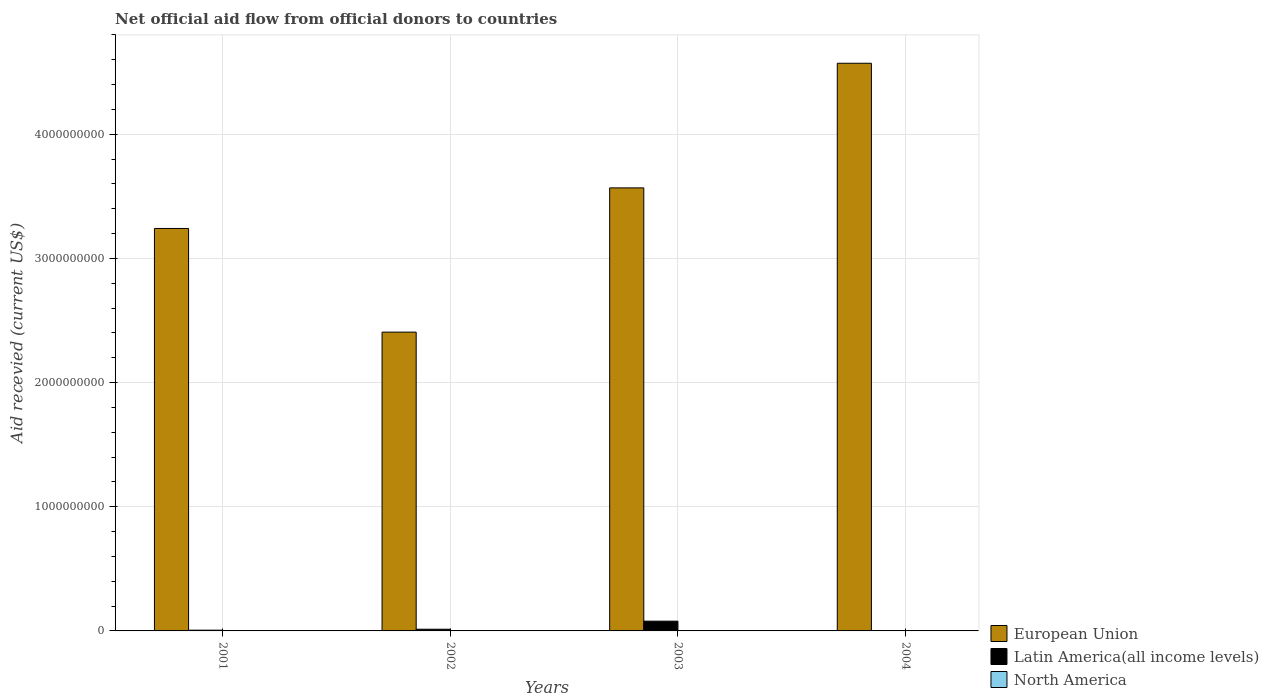How many groups of bars are there?
Provide a short and direct response. 4. Are the number of bars on each tick of the X-axis equal?
Ensure brevity in your answer.  No. How many bars are there on the 4th tick from the left?
Make the answer very short. 2. How many bars are there on the 1st tick from the right?
Make the answer very short. 2. What is the total aid received in North America in 2003?
Make the answer very short. 3.00e+04. Across all years, what is the maximum total aid received in European Union?
Offer a terse response. 4.57e+09. What is the difference between the total aid received in North America in 2001 and that in 2002?
Ensure brevity in your answer.  0. What is the difference between the total aid received in European Union in 2003 and the total aid received in Latin America(all income levels) in 2002?
Ensure brevity in your answer.  3.55e+09. What is the average total aid received in Latin America(all income levels) per year?
Offer a terse response. 2.46e+07. In the year 2002, what is the difference between the total aid received in Latin America(all income levels) and total aid received in North America?
Ensure brevity in your answer.  1.37e+07. In how many years, is the total aid received in European Union greater than 3600000000 US$?
Keep it short and to the point. 1. What is the ratio of the total aid received in European Union in 2001 to that in 2002?
Provide a short and direct response. 1.35. What is the difference between the highest and the second highest total aid received in Latin America(all income levels)?
Your answer should be compact. 6.49e+07. Is the sum of the total aid received in European Union in 2002 and 2003 greater than the maximum total aid received in North America across all years?
Make the answer very short. Yes. How many bars are there?
Keep it short and to the point. 11. Are all the bars in the graph horizontal?
Provide a succinct answer. No. How many years are there in the graph?
Make the answer very short. 4. Are the values on the major ticks of Y-axis written in scientific E-notation?
Make the answer very short. No. Does the graph contain grids?
Offer a very short reply. Yes. Where does the legend appear in the graph?
Make the answer very short. Bottom right. How are the legend labels stacked?
Keep it short and to the point. Vertical. What is the title of the graph?
Ensure brevity in your answer.  Net official aid flow from official donors to countries. What is the label or title of the Y-axis?
Your answer should be compact. Aid recevied (current US$). What is the Aid recevied (current US$) in European Union in 2001?
Give a very brief answer. 3.24e+09. What is the Aid recevied (current US$) of Latin America(all income levels) in 2001?
Provide a short and direct response. 5.97e+06. What is the Aid recevied (current US$) in North America in 2001?
Your response must be concise. 2.00e+04. What is the Aid recevied (current US$) of European Union in 2002?
Offer a very short reply. 2.41e+09. What is the Aid recevied (current US$) in Latin America(all income levels) in 2002?
Offer a very short reply. 1.37e+07. What is the Aid recevied (current US$) in North America in 2002?
Provide a short and direct response. 2.00e+04. What is the Aid recevied (current US$) in European Union in 2003?
Provide a short and direct response. 3.57e+09. What is the Aid recevied (current US$) of Latin America(all income levels) in 2003?
Give a very brief answer. 7.86e+07. What is the Aid recevied (current US$) in European Union in 2004?
Ensure brevity in your answer.  4.57e+09. Across all years, what is the maximum Aid recevied (current US$) of European Union?
Make the answer very short. 4.57e+09. Across all years, what is the maximum Aid recevied (current US$) of Latin America(all income levels)?
Ensure brevity in your answer.  7.86e+07. Across all years, what is the minimum Aid recevied (current US$) in European Union?
Give a very brief answer. 2.41e+09. Across all years, what is the minimum Aid recevied (current US$) in Latin America(all income levels)?
Ensure brevity in your answer.  0. Across all years, what is the minimum Aid recevied (current US$) in North America?
Make the answer very short. 2.00e+04. What is the total Aid recevied (current US$) in European Union in the graph?
Offer a very short reply. 1.38e+1. What is the total Aid recevied (current US$) of Latin America(all income levels) in the graph?
Keep it short and to the point. 9.82e+07. What is the total Aid recevied (current US$) of North America in the graph?
Your answer should be compact. 1.60e+05. What is the difference between the Aid recevied (current US$) in European Union in 2001 and that in 2002?
Give a very brief answer. 8.35e+08. What is the difference between the Aid recevied (current US$) in Latin America(all income levels) in 2001 and that in 2002?
Provide a succinct answer. -7.74e+06. What is the difference between the Aid recevied (current US$) of North America in 2001 and that in 2002?
Offer a terse response. 0. What is the difference between the Aid recevied (current US$) of European Union in 2001 and that in 2003?
Make the answer very short. -3.27e+08. What is the difference between the Aid recevied (current US$) of Latin America(all income levels) in 2001 and that in 2003?
Offer a very short reply. -7.26e+07. What is the difference between the Aid recevied (current US$) of European Union in 2001 and that in 2004?
Give a very brief answer. -1.33e+09. What is the difference between the Aid recevied (current US$) of North America in 2001 and that in 2004?
Give a very brief answer. -7.00e+04. What is the difference between the Aid recevied (current US$) in European Union in 2002 and that in 2003?
Your answer should be compact. -1.16e+09. What is the difference between the Aid recevied (current US$) in Latin America(all income levels) in 2002 and that in 2003?
Give a very brief answer. -6.49e+07. What is the difference between the Aid recevied (current US$) in European Union in 2002 and that in 2004?
Provide a succinct answer. -2.17e+09. What is the difference between the Aid recevied (current US$) of European Union in 2003 and that in 2004?
Your answer should be compact. -1.00e+09. What is the difference between the Aid recevied (current US$) of European Union in 2001 and the Aid recevied (current US$) of Latin America(all income levels) in 2002?
Offer a very short reply. 3.23e+09. What is the difference between the Aid recevied (current US$) of European Union in 2001 and the Aid recevied (current US$) of North America in 2002?
Provide a short and direct response. 3.24e+09. What is the difference between the Aid recevied (current US$) of Latin America(all income levels) in 2001 and the Aid recevied (current US$) of North America in 2002?
Give a very brief answer. 5.95e+06. What is the difference between the Aid recevied (current US$) of European Union in 2001 and the Aid recevied (current US$) of Latin America(all income levels) in 2003?
Your answer should be very brief. 3.16e+09. What is the difference between the Aid recevied (current US$) in European Union in 2001 and the Aid recevied (current US$) in North America in 2003?
Make the answer very short. 3.24e+09. What is the difference between the Aid recevied (current US$) of Latin America(all income levels) in 2001 and the Aid recevied (current US$) of North America in 2003?
Provide a succinct answer. 5.94e+06. What is the difference between the Aid recevied (current US$) in European Union in 2001 and the Aid recevied (current US$) in North America in 2004?
Offer a terse response. 3.24e+09. What is the difference between the Aid recevied (current US$) of Latin America(all income levels) in 2001 and the Aid recevied (current US$) of North America in 2004?
Offer a terse response. 5.88e+06. What is the difference between the Aid recevied (current US$) in European Union in 2002 and the Aid recevied (current US$) in Latin America(all income levels) in 2003?
Your answer should be compact. 2.33e+09. What is the difference between the Aid recevied (current US$) of European Union in 2002 and the Aid recevied (current US$) of North America in 2003?
Your response must be concise. 2.41e+09. What is the difference between the Aid recevied (current US$) of Latin America(all income levels) in 2002 and the Aid recevied (current US$) of North America in 2003?
Your answer should be very brief. 1.37e+07. What is the difference between the Aid recevied (current US$) of European Union in 2002 and the Aid recevied (current US$) of North America in 2004?
Offer a terse response. 2.41e+09. What is the difference between the Aid recevied (current US$) of Latin America(all income levels) in 2002 and the Aid recevied (current US$) of North America in 2004?
Ensure brevity in your answer.  1.36e+07. What is the difference between the Aid recevied (current US$) of European Union in 2003 and the Aid recevied (current US$) of North America in 2004?
Your answer should be very brief. 3.57e+09. What is the difference between the Aid recevied (current US$) in Latin America(all income levels) in 2003 and the Aid recevied (current US$) in North America in 2004?
Your response must be concise. 7.85e+07. What is the average Aid recevied (current US$) in European Union per year?
Your answer should be compact. 3.45e+09. What is the average Aid recevied (current US$) in Latin America(all income levels) per year?
Your answer should be very brief. 2.46e+07. In the year 2001, what is the difference between the Aid recevied (current US$) of European Union and Aid recevied (current US$) of Latin America(all income levels)?
Give a very brief answer. 3.24e+09. In the year 2001, what is the difference between the Aid recevied (current US$) of European Union and Aid recevied (current US$) of North America?
Provide a short and direct response. 3.24e+09. In the year 2001, what is the difference between the Aid recevied (current US$) of Latin America(all income levels) and Aid recevied (current US$) of North America?
Provide a short and direct response. 5.95e+06. In the year 2002, what is the difference between the Aid recevied (current US$) in European Union and Aid recevied (current US$) in Latin America(all income levels)?
Keep it short and to the point. 2.39e+09. In the year 2002, what is the difference between the Aid recevied (current US$) of European Union and Aid recevied (current US$) of North America?
Ensure brevity in your answer.  2.41e+09. In the year 2002, what is the difference between the Aid recevied (current US$) of Latin America(all income levels) and Aid recevied (current US$) of North America?
Your answer should be compact. 1.37e+07. In the year 2003, what is the difference between the Aid recevied (current US$) in European Union and Aid recevied (current US$) in Latin America(all income levels)?
Your response must be concise. 3.49e+09. In the year 2003, what is the difference between the Aid recevied (current US$) in European Union and Aid recevied (current US$) in North America?
Your answer should be compact. 3.57e+09. In the year 2003, what is the difference between the Aid recevied (current US$) of Latin America(all income levels) and Aid recevied (current US$) of North America?
Provide a succinct answer. 7.85e+07. In the year 2004, what is the difference between the Aid recevied (current US$) in European Union and Aid recevied (current US$) in North America?
Keep it short and to the point. 4.57e+09. What is the ratio of the Aid recevied (current US$) in European Union in 2001 to that in 2002?
Your answer should be very brief. 1.35. What is the ratio of the Aid recevied (current US$) in Latin America(all income levels) in 2001 to that in 2002?
Your answer should be very brief. 0.44. What is the ratio of the Aid recevied (current US$) in European Union in 2001 to that in 2003?
Give a very brief answer. 0.91. What is the ratio of the Aid recevied (current US$) in Latin America(all income levels) in 2001 to that in 2003?
Your answer should be compact. 0.08. What is the ratio of the Aid recevied (current US$) in European Union in 2001 to that in 2004?
Offer a very short reply. 0.71. What is the ratio of the Aid recevied (current US$) of North America in 2001 to that in 2004?
Keep it short and to the point. 0.22. What is the ratio of the Aid recevied (current US$) in European Union in 2002 to that in 2003?
Your answer should be very brief. 0.67. What is the ratio of the Aid recevied (current US$) of Latin America(all income levels) in 2002 to that in 2003?
Ensure brevity in your answer.  0.17. What is the ratio of the Aid recevied (current US$) of North America in 2002 to that in 2003?
Keep it short and to the point. 0.67. What is the ratio of the Aid recevied (current US$) of European Union in 2002 to that in 2004?
Provide a succinct answer. 0.53. What is the ratio of the Aid recevied (current US$) of North America in 2002 to that in 2004?
Keep it short and to the point. 0.22. What is the ratio of the Aid recevied (current US$) of European Union in 2003 to that in 2004?
Your response must be concise. 0.78. What is the difference between the highest and the second highest Aid recevied (current US$) in European Union?
Offer a terse response. 1.00e+09. What is the difference between the highest and the second highest Aid recevied (current US$) of Latin America(all income levels)?
Give a very brief answer. 6.49e+07. What is the difference between the highest and the lowest Aid recevied (current US$) of European Union?
Offer a terse response. 2.17e+09. What is the difference between the highest and the lowest Aid recevied (current US$) in Latin America(all income levels)?
Provide a short and direct response. 7.86e+07. What is the difference between the highest and the lowest Aid recevied (current US$) in North America?
Offer a terse response. 7.00e+04. 